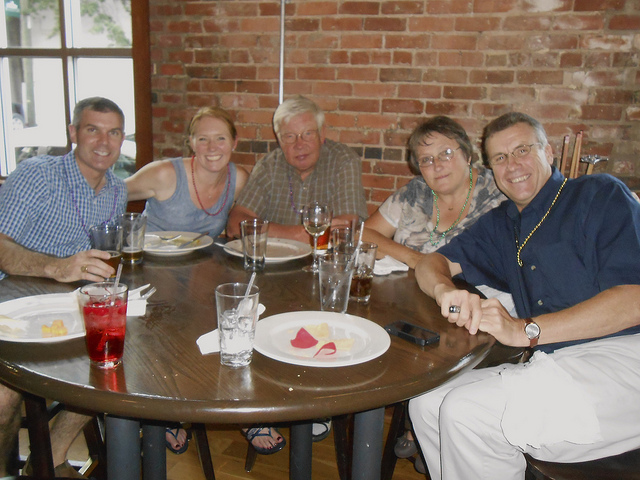<image>Are they related? I don't know if they are related. However, it can be yes or no. Are they related? I am not sure if they are related. 